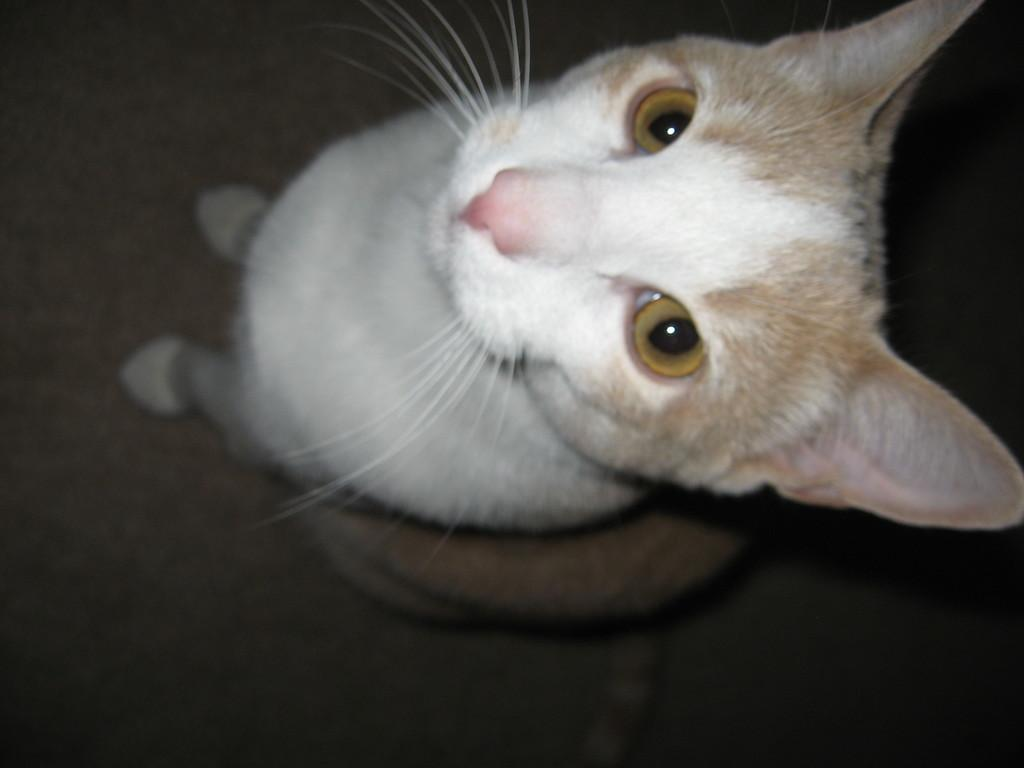What type of animal is present in the image? There is a cat in the image. Can you describe the color of the cat? The cat is white and brown in color. How many rabbits are hopping around the cat in the image? There are no rabbits present in the image; it only features a cat. What type of stick is the cat holding in the image? There is no stick present in the image. 